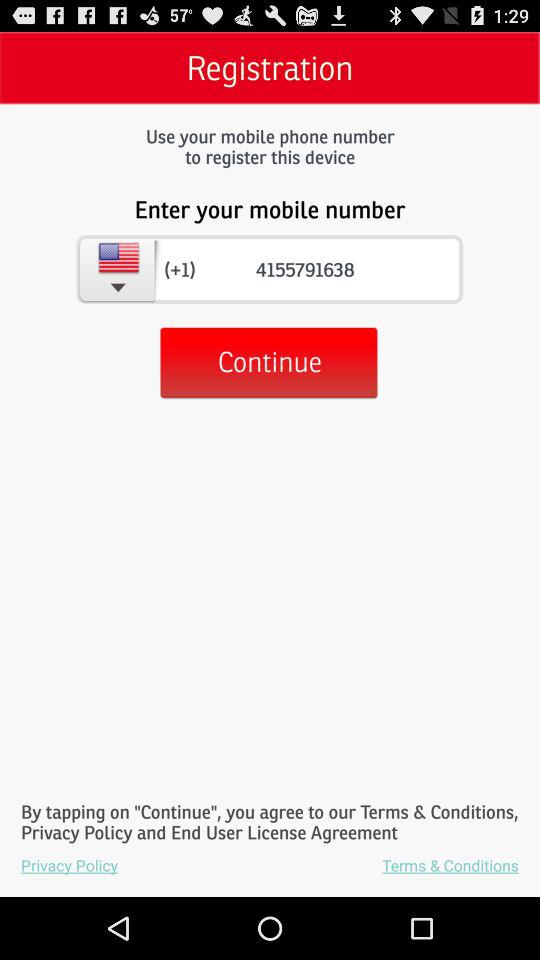Which state code is showing?
When the provided information is insufficient, respond with <no answer>. <no answer> 